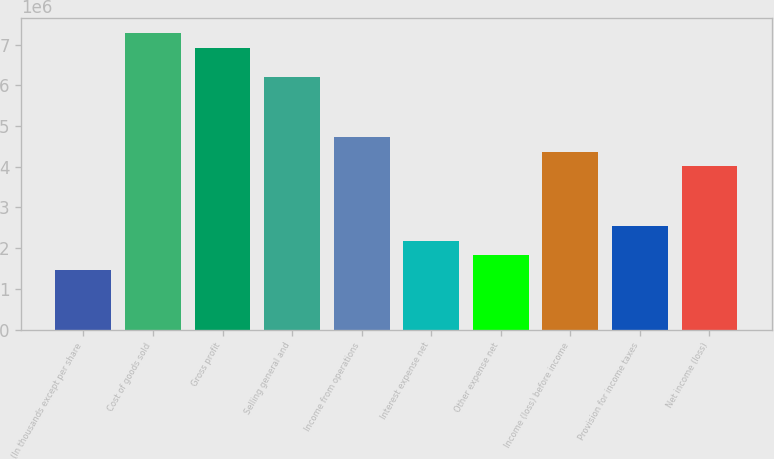Convert chart. <chart><loc_0><loc_0><loc_500><loc_500><bar_chart><fcel>(In thousands except per share<fcel>Cost of goods sold<fcel>Gross profit<fcel>Selling general and<fcel>Income from operations<fcel>Interest expense net<fcel>Other expense net<fcel>Income (loss) before income<fcel>Provision for income taxes<fcel>Net income (loss)<nl><fcel>1.45773e+06<fcel>7.28866e+06<fcel>6.92423e+06<fcel>6.19536e+06<fcel>4.73763e+06<fcel>2.1866e+06<fcel>1.82217e+06<fcel>4.3732e+06<fcel>2.55103e+06<fcel>4.00876e+06<nl></chart> 